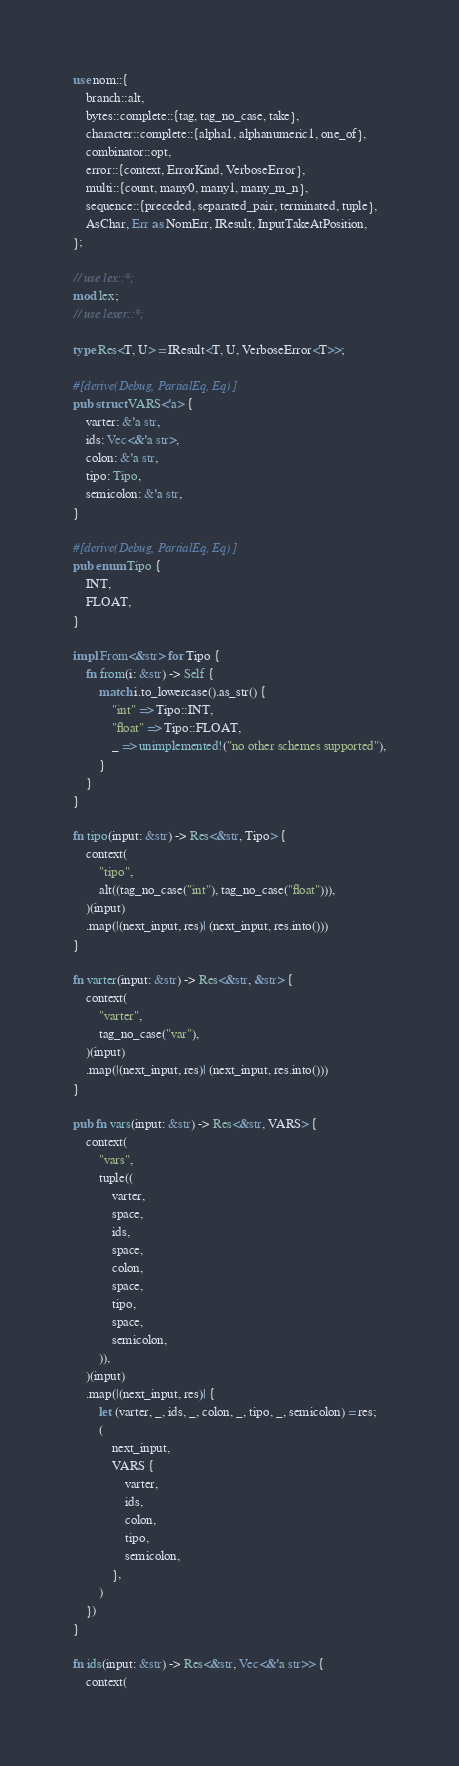Convert code to text. <code><loc_0><loc_0><loc_500><loc_500><_Rust_>use nom::{
    branch::alt,
    bytes::complete::{tag, tag_no_case, take},
    character::complete::{alpha1, alphanumeric1, one_of},
    combinator::opt,
    error::{context, ErrorKind, VerboseError},
    multi::{count, many0, many1, many_m_n},
    sequence::{preceded, separated_pair, terminated, tuple},
    AsChar, Err as NomErr, IResult, InputTakeAtPosition,
};

// use lex::*;
mod lex;
// use lexer::*;

type Res<T, U> = IResult<T, U, VerboseError<T>>;

#[derive(Debug, PartialEq, Eq)]
pub struct VARS<'a> {
    varter: &'a str,
    ids: Vec<&'a str>,
    colon: &'a str,
    tipo: Tipo,
    semicolon: &'a str,
}

#[derive(Debug, PartialEq, Eq)]
pub enum Tipo {
    INT,
    FLOAT,
}

impl From<&str> for Tipo {
    fn from(i: &str) -> Self {
        match i.to_lowercase().as_str() {
            "int" => Tipo::INT,
            "float" => Tipo::FLOAT,
            _ => unimplemented!("no other schemes supported"),
        }
    }
}

fn tipo(input: &str) -> Res<&str, Tipo> {
    context(
        "tipo",
        alt((tag_no_case("int"), tag_no_case("float"))),
    )(input)
    .map(|(next_input, res)| (next_input, res.into()))
}

fn varter(input: &str) -> Res<&str, &str> {
    context(
        "varter",
        tag_no_case("var"),
    )(input)
    .map(|(next_input, res)| (next_input, res.into()))
}

pub fn vars(input: &str) -> Res<&str, VARS> {
    context(
        "vars",
        tuple((
            varter,
            space,
            ids,
            space,
            colon,
            space,
            tipo,
            space,
            semicolon,
        )),
    )(input)
    .map(|(next_input, res)| {
        let (varter, _, ids, _, colon, _, tipo, _, semicolon) = res;
        (
            next_input,
            VARS {
                varter,
                ids,
                colon,
                tipo,
                semicolon,
            },
        )
    })
}

fn ids(input: &str) -> Res<&str, Vec<&'a str>> {
    context(</code> 